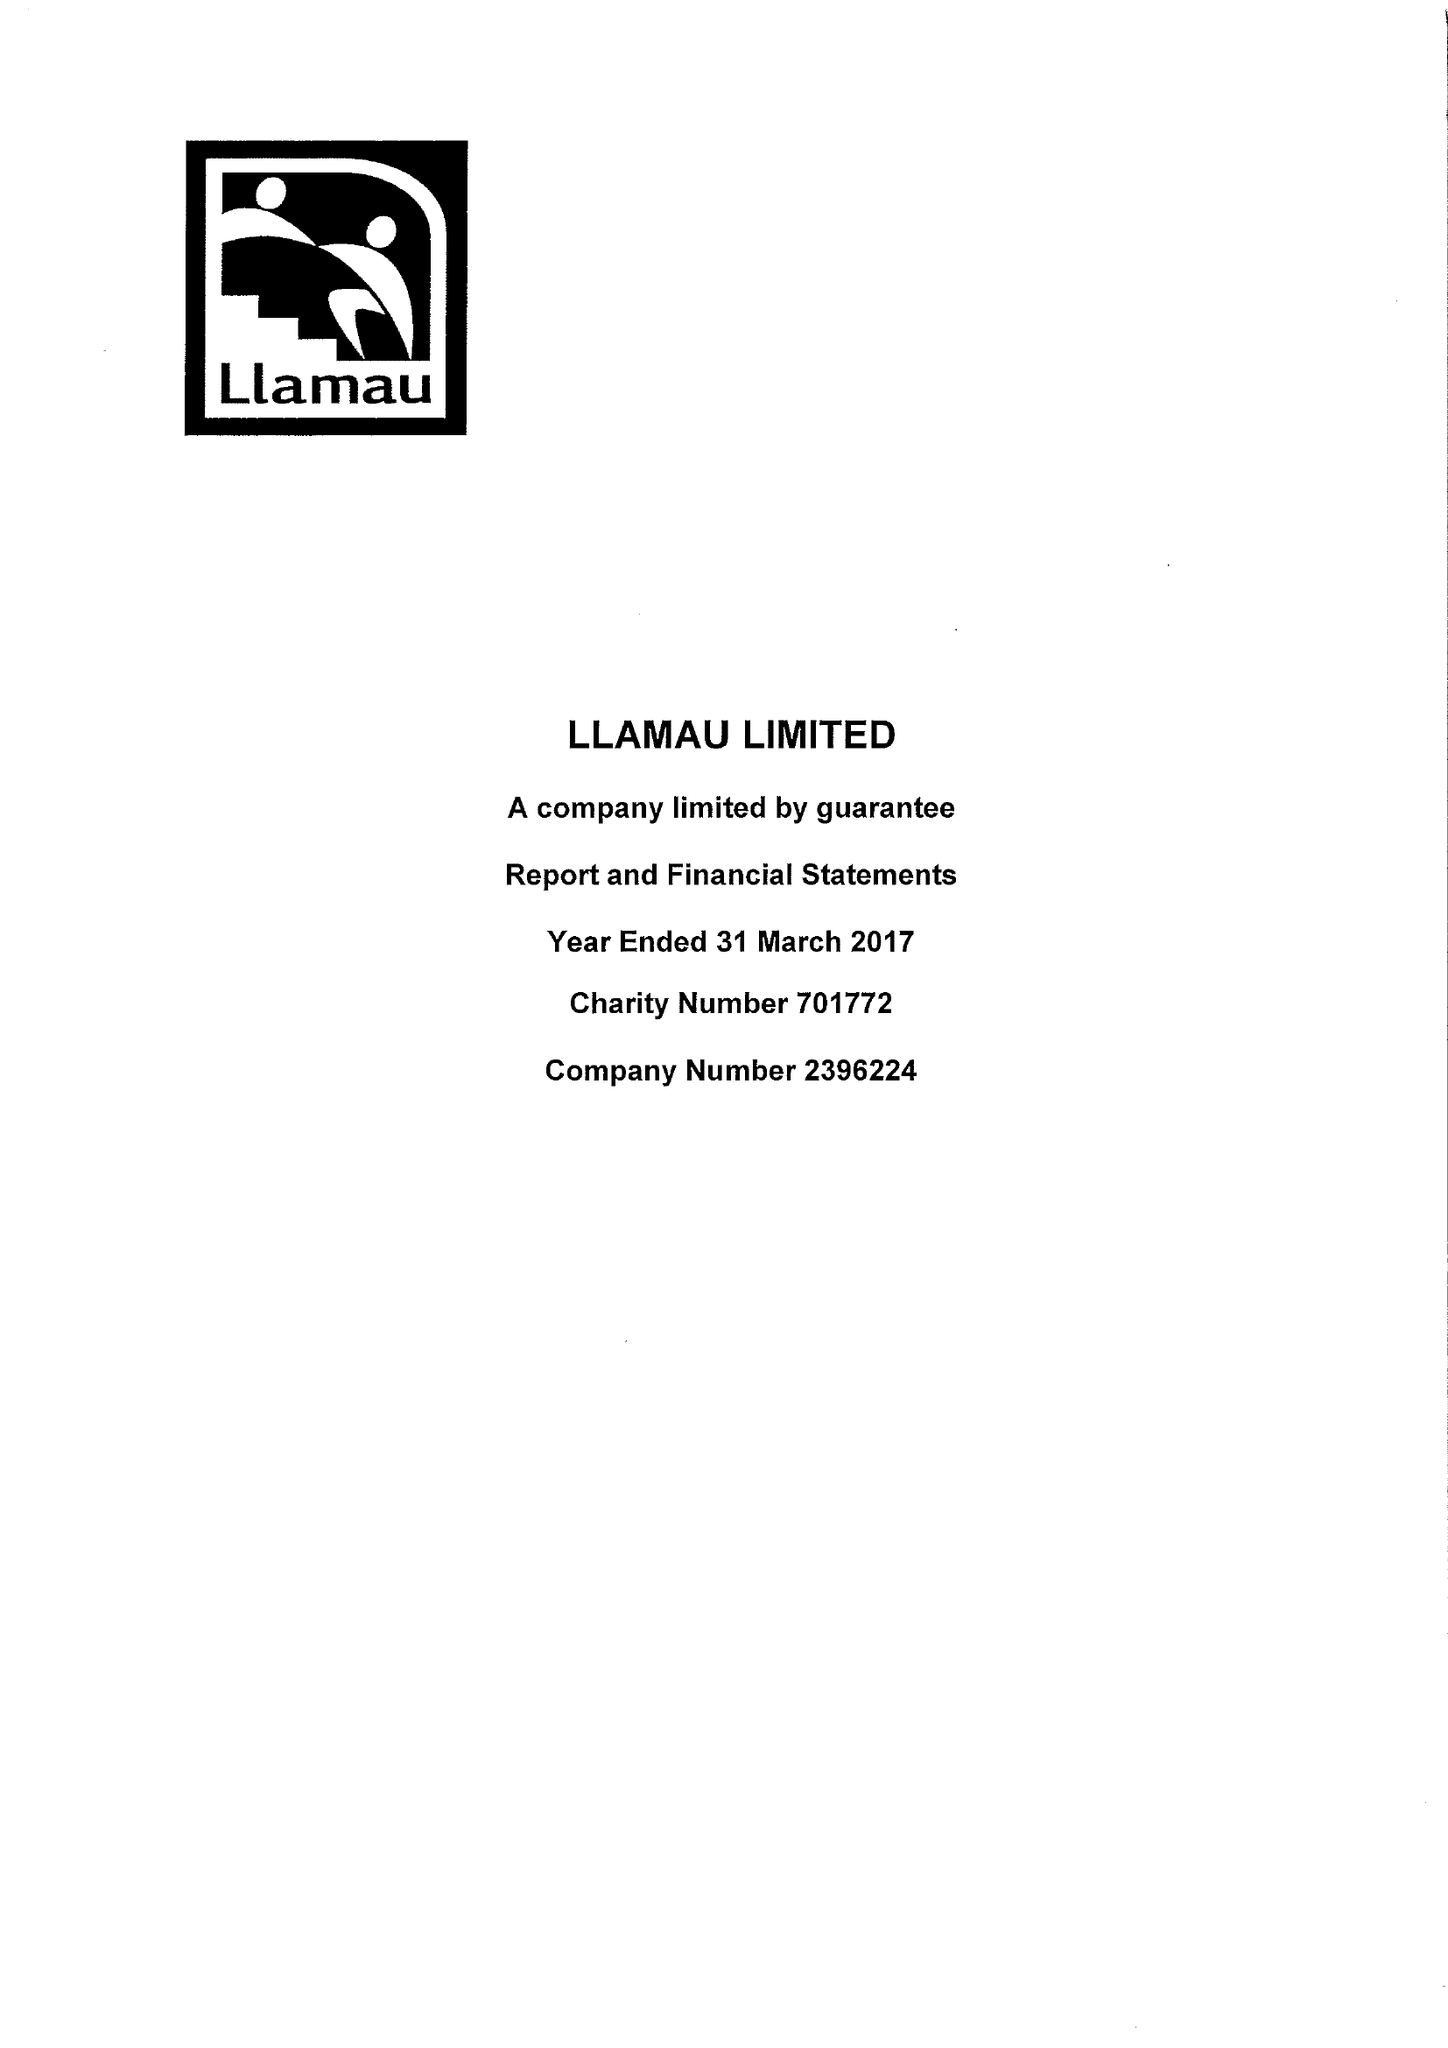What is the value for the report_date?
Answer the question using a single word or phrase. 2017-03-31 